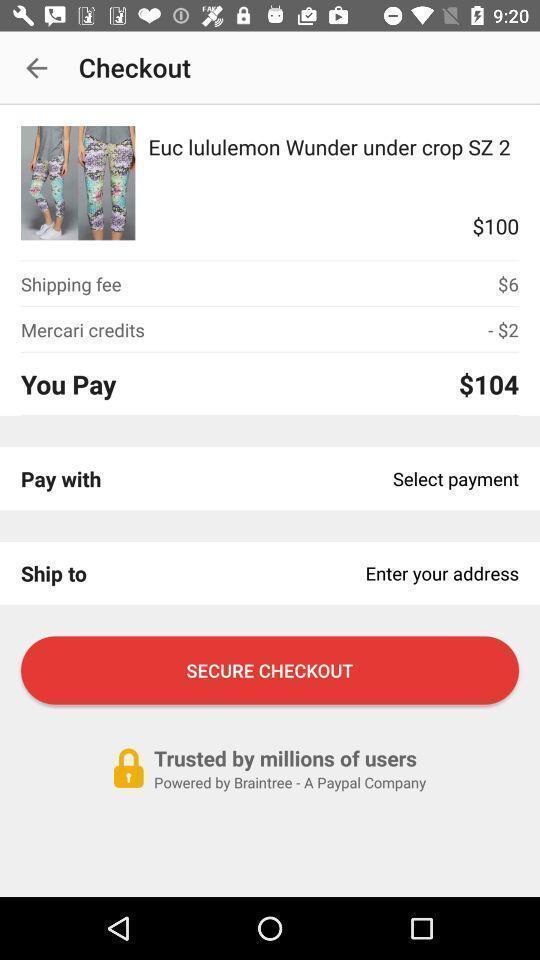Explain the elements present in this screenshot. Secure checkout to check out. 